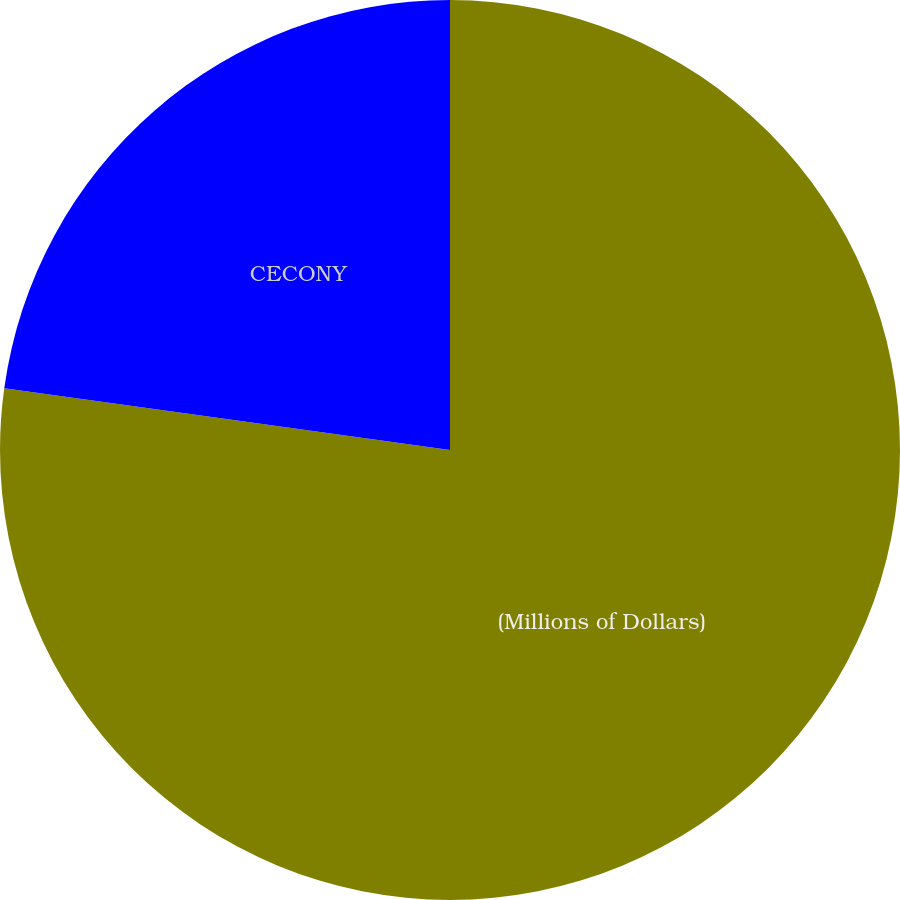Convert chart to OTSL. <chart><loc_0><loc_0><loc_500><loc_500><pie_chart><fcel>(Millions of Dollars)<fcel>CECONY<nl><fcel>77.19%<fcel>22.81%<nl></chart> 